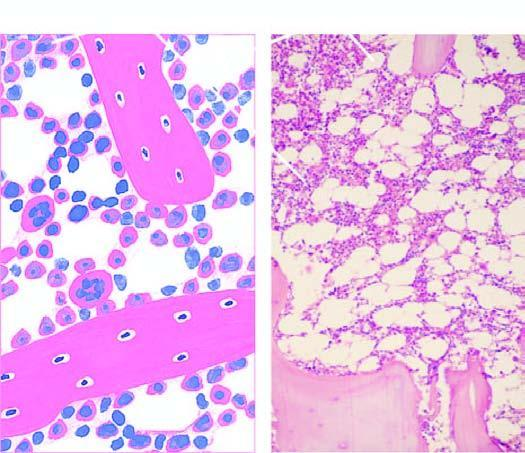s normal bone marrow in an adult seen in a section after trephine biopsy?
Answer the question using a single word or phrase. Yes 